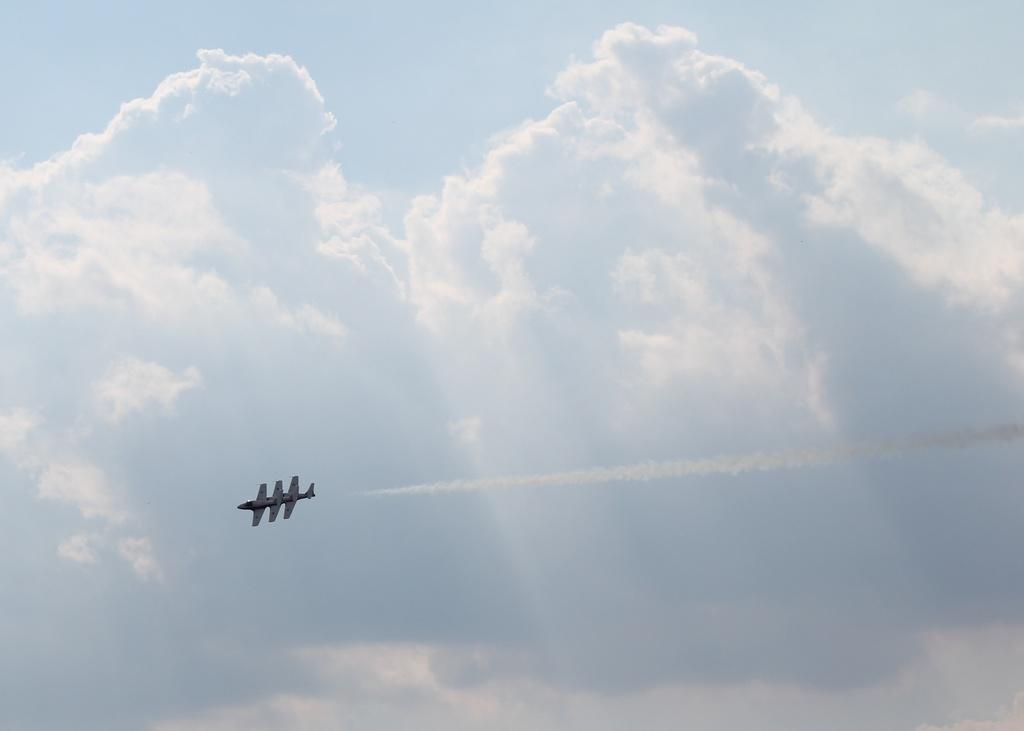What is the main subject of the image? The main subject of the image is an aircraft flying. What can be seen in the background of the image? The sky is visible in the background of the image. What is the condition of the sky in the image? Clouds are present in the sky. What type of yarn is being used to create the church in the image? There is no church or yarn present in the image; it features an aircraft flying in the sky. What instrument is being played by the people in the image? There are no people or instruments present in the image. 